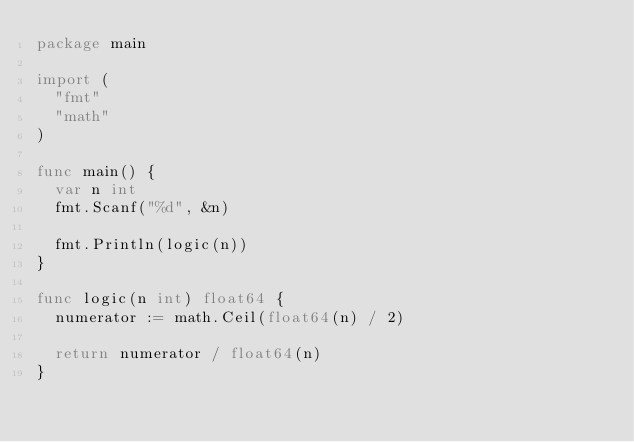Convert code to text. <code><loc_0><loc_0><loc_500><loc_500><_Go_>package main

import (
	"fmt"
	"math"
)

func main() {
	var n int
	fmt.Scanf("%d", &n)

	fmt.Println(logic(n))
}

func logic(n int) float64 {
	numerator := math.Ceil(float64(n) / 2)

	return numerator / float64(n)
}</code> 